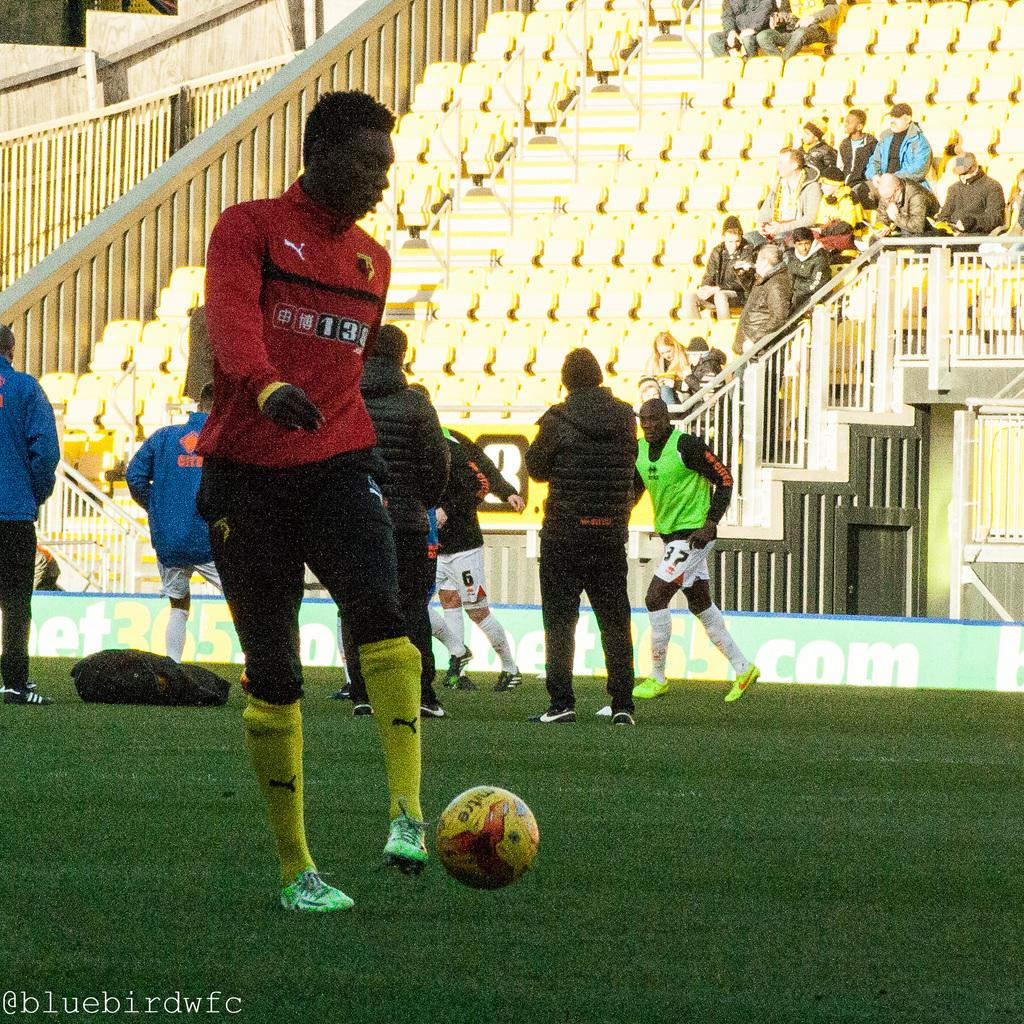What are the people in the image doing? There are persons standing and sitting in the image. What object can be seen in the image that is typically used for playing games? There is a ball in the image. What type of surface is visible in the image? There is grass in the image. What type of furniture is present in the image? There are chairs in the image. What type of structure is visible in the background of the image? There is a hoarding in the image. What type of string is being used to play a musical instrument in the image? There is no string or musical instrument present in the image. What type of church can be seen in the image? There is no church present in the image. 